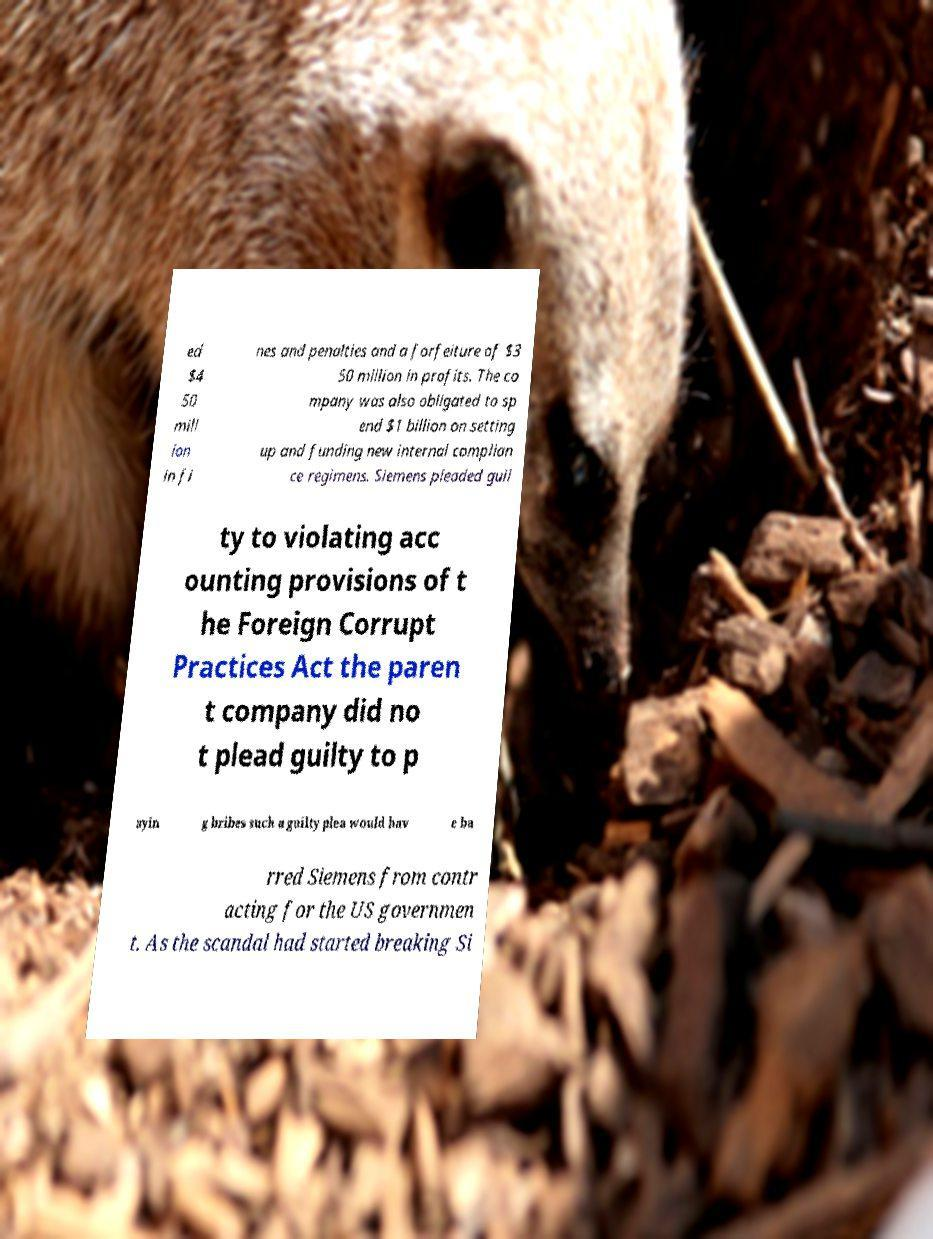Can you read and provide the text displayed in the image?This photo seems to have some interesting text. Can you extract and type it out for me? ed $4 50 mill ion in fi nes and penalties and a forfeiture of $3 50 million in profits. The co mpany was also obligated to sp end $1 billion on setting up and funding new internal complian ce regimens. Siemens pleaded guil ty to violating acc ounting provisions of t he Foreign Corrupt Practices Act the paren t company did no t plead guilty to p ayin g bribes such a guilty plea would hav e ba rred Siemens from contr acting for the US governmen t. As the scandal had started breaking Si 